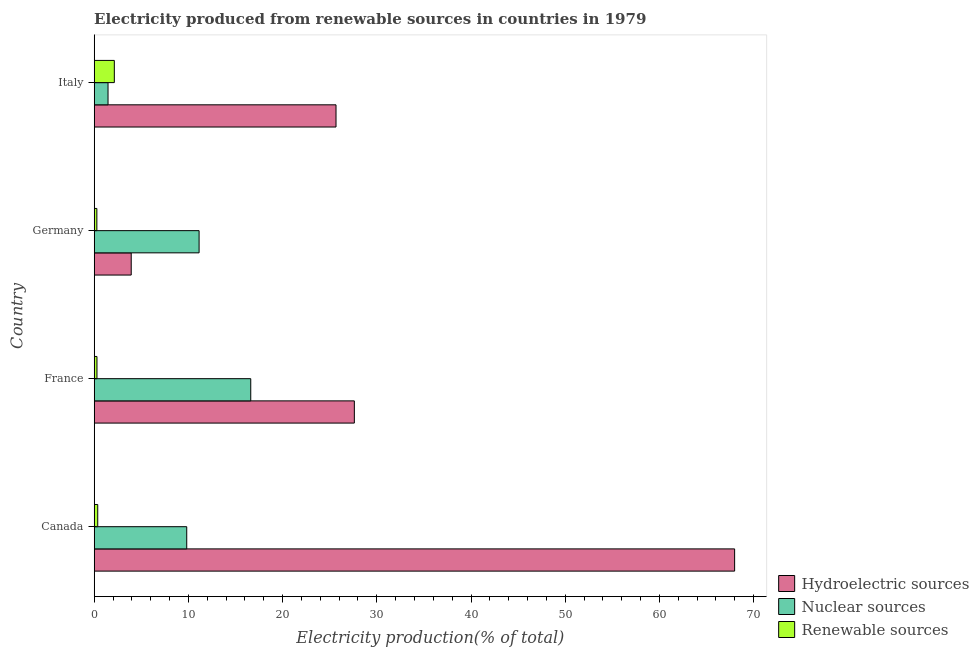How many different coloured bars are there?
Provide a short and direct response. 3. Are the number of bars per tick equal to the number of legend labels?
Your answer should be very brief. Yes. How many bars are there on the 1st tick from the bottom?
Offer a terse response. 3. What is the label of the 4th group of bars from the top?
Keep it short and to the point. Canada. What is the percentage of electricity produced by nuclear sources in Germany?
Make the answer very short. 11.13. Across all countries, what is the maximum percentage of electricity produced by hydroelectric sources?
Provide a succinct answer. 67.98. Across all countries, what is the minimum percentage of electricity produced by renewable sources?
Make the answer very short. 0.28. In which country was the percentage of electricity produced by hydroelectric sources minimum?
Give a very brief answer. Germany. What is the total percentage of electricity produced by nuclear sources in the graph?
Offer a terse response. 39.04. What is the difference between the percentage of electricity produced by hydroelectric sources in France and that in Germany?
Ensure brevity in your answer.  23.68. What is the difference between the percentage of electricity produced by hydroelectric sources in Canada and the percentage of electricity produced by nuclear sources in Italy?
Ensure brevity in your answer.  66.51. What is the average percentage of electricity produced by renewable sources per country?
Your answer should be compact. 0.77. What is the difference between the percentage of electricity produced by hydroelectric sources and percentage of electricity produced by nuclear sources in Germany?
Your response must be concise. -7.21. In how many countries, is the percentage of electricity produced by nuclear sources greater than 4 %?
Ensure brevity in your answer.  3. What is the ratio of the percentage of electricity produced by renewable sources in Canada to that in France?
Keep it short and to the point. 1.27. Is the difference between the percentage of electricity produced by hydroelectric sources in Canada and Italy greater than the difference between the percentage of electricity produced by nuclear sources in Canada and Italy?
Provide a short and direct response. Yes. What is the difference between the highest and the second highest percentage of electricity produced by renewable sources?
Make the answer very short. 1.76. What is the difference between the highest and the lowest percentage of electricity produced by nuclear sources?
Offer a very short reply. 15.15. Is the sum of the percentage of electricity produced by hydroelectric sources in France and Italy greater than the maximum percentage of electricity produced by renewable sources across all countries?
Provide a succinct answer. Yes. What does the 2nd bar from the top in Italy represents?
Make the answer very short. Nuclear sources. What does the 3rd bar from the bottom in Germany represents?
Provide a succinct answer. Renewable sources. What is the difference between two consecutive major ticks on the X-axis?
Provide a succinct answer. 10. Does the graph contain any zero values?
Your response must be concise. No. Does the graph contain grids?
Provide a short and direct response. No. How many legend labels are there?
Your response must be concise. 3. How are the legend labels stacked?
Your answer should be compact. Vertical. What is the title of the graph?
Provide a short and direct response. Electricity produced from renewable sources in countries in 1979. Does "Oil" appear as one of the legend labels in the graph?
Offer a very short reply. No. What is the Electricity production(% of total) in Hydroelectric sources in Canada?
Ensure brevity in your answer.  67.98. What is the Electricity production(% of total) of Nuclear sources in Canada?
Ensure brevity in your answer.  9.82. What is the Electricity production(% of total) of Renewable sources in Canada?
Provide a short and direct response. 0.37. What is the Electricity production(% of total) of Hydroelectric sources in France?
Make the answer very short. 27.61. What is the Electricity production(% of total) of Nuclear sources in France?
Provide a short and direct response. 16.62. What is the Electricity production(% of total) of Renewable sources in France?
Your answer should be compact. 0.29. What is the Electricity production(% of total) in Hydroelectric sources in Germany?
Your answer should be compact. 3.93. What is the Electricity production(% of total) of Nuclear sources in Germany?
Give a very brief answer. 11.13. What is the Electricity production(% of total) of Renewable sources in Germany?
Your answer should be compact. 0.28. What is the Electricity production(% of total) in Hydroelectric sources in Italy?
Your answer should be very brief. 25.67. What is the Electricity production(% of total) of Nuclear sources in Italy?
Give a very brief answer. 1.47. What is the Electricity production(% of total) of Renewable sources in Italy?
Give a very brief answer. 2.14. Across all countries, what is the maximum Electricity production(% of total) in Hydroelectric sources?
Provide a short and direct response. 67.98. Across all countries, what is the maximum Electricity production(% of total) in Nuclear sources?
Provide a succinct answer. 16.62. Across all countries, what is the maximum Electricity production(% of total) of Renewable sources?
Your response must be concise. 2.14. Across all countries, what is the minimum Electricity production(% of total) in Hydroelectric sources?
Provide a short and direct response. 3.93. Across all countries, what is the minimum Electricity production(% of total) of Nuclear sources?
Give a very brief answer. 1.47. Across all countries, what is the minimum Electricity production(% of total) of Renewable sources?
Your answer should be compact. 0.28. What is the total Electricity production(% of total) of Hydroelectric sources in the graph?
Your response must be concise. 125.19. What is the total Electricity production(% of total) in Nuclear sources in the graph?
Ensure brevity in your answer.  39.04. What is the total Electricity production(% of total) of Renewable sources in the graph?
Your response must be concise. 3.09. What is the difference between the Electricity production(% of total) of Hydroelectric sources in Canada and that in France?
Your response must be concise. 40.37. What is the difference between the Electricity production(% of total) of Nuclear sources in Canada and that in France?
Ensure brevity in your answer.  -6.8. What is the difference between the Electricity production(% of total) in Renewable sources in Canada and that in France?
Offer a very short reply. 0.08. What is the difference between the Electricity production(% of total) in Hydroelectric sources in Canada and that in Germany?
Offer a terse response. 64.05. What is the difference between the Electricity production(% of total) of Nuclear sources in Canada and that in Germany?
Provide a succinct answer. -1.31. What is the difference between the Electricity production(% of total) in Renewable sources in Canada and that in Germany?
Offer a very short reply. 0.09. What is the difference between the Electricity production(% of total) of Hydroelectric sources in Canada and that in Italy?
Make the answer very short. 42.31. What is the difference between the Electricity production(% of total) of Nuclear sources in Canada and that in Italy?
Keep it short and to the point. 8.35. What is the difference between the Electricity production(% of total) of Renewable sources in Canada and that in Italy?
Your answer should be very brief. -1.76. What is the difference between the Electricity production(% of total) of Hydroelectric sources in France and that in Germany?
Ensure brevity in your answer.  23.68. What is the difference between the Electricity production(% of total) in Nuclear sources in France and that in Germany?
Give a very brief answer. 5.48. What is the difference between the Electricity production(% of total) in Renewable sources in France and that in Germany?
Offer a terse response. 0.01. What is the difference between the Electricity production(% of total) in Hydroelectric sources in France and that in Italy?
Ensure brevity in your answer.  1.95. What is the difference between the Electricity production(% of total) of Nuclear sources in France and that in Italy?
Provide a short and direct response. 15.15. What is the difference between the Electricity production(% of total) in Renewable sources in France and that in Italy?
Provide a short and direct response. -1.84. What is the difference between the Electricity production(% of total) in Hydroelectric sources in Germany and that in Italy?
Offer a very short reply. -21.74. What is the difference between the Electricity production(% of total) in Nuclear sources in Germany and that in Italy?
Your answer should be compact. 9.67. What is the difference between the Electricity production(% of total) in Renewable sources in Germany and that in Italy?
Offer a very short reply. -1.85. What is the difference between the Electricity production(% of total) of Hydroelectric sources in Canada and the Electricity production(% of total) of Nuclear sources in France?
Provide a succinct answer. 51.36. What is the difference between the Electricity production(% of total) in Hydroelectric sources in Canada and the Electricity production(% of total) in Renewable sources in France?
Your answer should be very brief. 67.69. What is the difference between the Electricity production(% of total) in Nuclear sources in Canada and the Electricity production(% of total) in Renewable sources in France?
Offer a very short reply. 9.53. What is the difference between the Electricity production(% of total) of Hydroelectric sources in Canada and the Electricity production(% of total) of Nuclear sources in Germany?
Your response must be concise. 56.84. What is the difference between the Electricity production(% of total) in Hydroelectric sources in Canada and the Electricity production(% of total) in Renewable sources in Germany?
Give a very brief answer. 67.7. What is the difference between the Electricity production(% of total) in Nuclear sources in Canada and the Electricity production(% of total) in Renewable sources in Germany?
Offer a terse response. 9.54. What is the difference between the Electricity production(% of total) in Hydroelectric sources in Canada and the Electricity production(% of total) in Nuclear sources in Italy?
Give a very brief answer. 66.51. What is the difference between the Electricity production(% of total) in Hydroelectric sources in Canada and the Electricity production(% of total) in Renewable sources in Italy?
Ensure brevity in your answer.  65.84. What is the difference between the Electricity production(% of total) of Nuclear sources in Canada and the Electricity production(% of total) of Renewable sources in Italy?
Give a very brief answer. 7.68. What is the difference between the Electricity production(% of total) in Hydroelectric sources in France and the Electricity production(% of total) in Nuclear sources in Germany?
Give a very brief answer. 16.48. What is the difference between the Electricity production(% of total) of Hydroelectric sources in France and the Electricity production(% of total) of Renewable sources in Germany?
Offer a terse response. 27.33. What is the difference between the Electricity production(% of total) in Nuclear sources in France and the Electricity production(% of total) in Renewable sources in Germany?
Your answer should be very brief. 16.33. What is the difference between the Electricity production(% of total) in Hydroelectric sources in France and the Electricity production(% of total) in Nuclear sources in Italy?
Provide a short and direct response. 26.15. What is the difference between the Electricity production(% of total) of Hydroelectric sources in France and the Electricity production(% of total) of Renewable sources in Italy?
Offer a very short reply. 25.48. What is the difference between the Electricity production(% of total) of Nuclear sources in France and the Electricity production(% of total) of Renewable sources in Italy?
Keep it short and to the point. 14.48. What is the difference between the Electricity production(% of total) of Hydroelectric sources in Germany and the Electricity production(% of total) of Nuclear sources in Italy?
Provide a short and direct response. 2.46. What is the difference between the Electricity production(% of total) in Hydroelectric sources in Germany and the Electricity production(% of total) in Renewable sources in Italy?
Offer a terse response. 1.79. What is the difference between the Electricity production(% of total) of Nuclear sources in Germany and the Electricity production(% of total) of Renewable sources in Italy?
Provide a short and direct response. 9. What is the average Electricity production(% of total) of Hydroelectric sources per country?
Keep it short and to the point. 31.3. What is the average Electricity production(% of total) in Nuclear sources per country?
Provide a succinct answer. 9.76. What is the average Electricity production(% of total) of Renewable sources per country?
Give a very brief answer. 0.77. What is the difference between the Electricity production(% of total) of Hydroelectric sources and Electricity production(% of total) of Nuclear sources in Canada?
Offer a terse response. 58.16. What is the difference between the Electricity production(% of total) in Hydroelectric sources and Electricity production(% of total) in Renewable sources in Canada?
Keep it short and to the point. 67.6. What is the difference between the Electricity production(% of total) in Nuclear sources and Electricity production(% of total) in Renewable sources in Canada?
Provide a succinct answer. 9.45. What is the difference between the Electricity production(% of total) in Hydroelectric sources and Electricity production(% of total) in Nuclear sources in France?
Make the answer very short. 11. What is the difference between the Electricity production(% of total) of Hydroelectric sources and Electricity production(% of total) of Renewable sources in France?
Make the answer very short. 27.32. What is the difference between the Electricity production(% of total) of Nuclear sources and Electricity production(% of total) of Renewable sources in France?
Keep it short and to the point. 16.32. What is the difference between the Electricity production(% of total) in Hydroelectric sources and Electricity production(% of total) in Nuclear sources in Germany?
Provide a short and direct response. -7.2. What is the difference between the Electricity production(% of total) of Hydroelectric sources and Electricity production(% of total) of Renewable sources in Germany?
Give a very brief answer. 3.65. What is the difference between the Electricity production(% of total) of Nuclear sources and Electricity production(% of total) of Renewable sources in Germany?
Make the answer very short. 10.85. What is the difference between the Electricity production(% of total) in Hydroelectric sources and Electricity production(% of total) in Nuclear sources in Italy?
Offer a terse response. 24.2. What is the difference between the Electricity production(% of total) of Hydroelectric sources and Electricity production(% of total) of Renewable sources in Italy?
Keep it short and to the point. 23.53. What is the difference between the Electricity production(% of total) in Nuclear sources and Electricity production(% of total) in Renewable sources in Italy?
Make the answer very short. -0.67. What is the ratio of the Electricity production(% of total) of Hydroelectric sources in Canada to that in France?
Provide a short and direct response. 2.46. What is the ratio of the Electricity production(% of total) of Nuclear sources in Canada to that in France?
Keep it short and to the point. 0.59. What is the ratio of the Electricity production(% of total) in Renewable sources in Canada to that in France?
Give a very brief answer. 1.27. What is the ratio of the Electricity production(% of total) of Hydroelectric sources in Canada to that in Germany?
Make the answer very short. 17.3. What is the ratio of the Electricity production(% of total) in Nuclear sources in Canada to that in Germany?
Your response must be concise. 0.88. What is the ratio of the Electricity production(% of total) of Renewable sources in Canada to that in Germany?
Offer a terse response. 1.32. What is the ratio of the Electricity production(% of total) of Hydroelectric sources in Canada to that in Italy?
Make the answer very short. 2.65. What is the ratio of the Electricity production(% of total) in Nuclear sources in Canada to that in Italy?
Ensure brevity in your answer.  6.69. What is the ratio of the Electricity production(% of total) of Renewable sources in Canada to that in Italy?
Your answer should be very brief. 0.18. What is the ratio of the Electricity production(% of total) in Hydroelectric sources in France to that in Germany?
Your answer should be compact. 7.03. What is the ratio of the Electricity production(% of total) in Nuclear sources in France to that in Germany?
Keep it short and to the point. 1.49. What is the ratio of the Electricity production(% of total) in Renewable sources in France to that in Germany?
Ensure brevity in your answer.  1.04. What is the ratio of the Electricity production(% of total) of Hydroelectric sources in France to that in Italy?
Offer a terse response. 1.08. What is the ratio of the Electricity production(% of total) in Nuclear sources in France to that in Italy?
Keep it short and to the point. 11.32. What is the ratio of the Electricity production(% of total) of Renewable sources in France to that in Italy?
Your response must be concise. 0.14. What is the ratio of the Electricity production(% of total) of Hydroelectric sources in Germany to that in Italy?
Your response must be concise. 0.15. What is the ratio of the Electricity production(% of total) of Nuclear sources in Germany to that in Italy?
Make the answer very short. 7.58. What is the ratio of the Electricity production(% of total) of Renewable sources in Germany to that in Italy?
Offer a terse response. 0.13. What is the difference between the highest and the second highest Electricity production(% of total) of Hydroelectric sources?
Offer a terse response. 40.37. What is the difference between the highest and the second highest Electricity production(% of total) of Nuclear sources?
Offer a very short reply. 5.48. What is the difference between the highest and the second highest Electricity production(% of total) in Renewable sources?
Keep it short and to the point. 1.76. What is the difference between the highest and the lowest Electricity production(% of total) in Hydroelectric sources?
Make the answer very short. 64.05. What is the difference between the highest and the lowest Electricity production(% of total) of Nuclear sources?
Give a very brief answer. 15.15. What is the difference between the highest and the lowest Electricity production(% of total) in Renewable sources?
Your answer should be very brief. 1.85. 